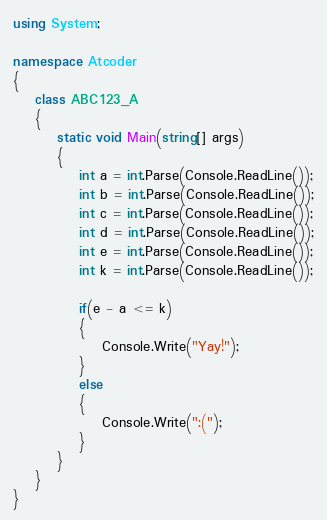<code> <loc_0><loc_0><loc_500><loc_500><_C#_>using System;

namespace Atcoder
{
    class ABC123_A
    {
        static void Main(string[] args)
        {
            int a = int.Parse(Console.ReadLine());
            int b = int.Parse(Console.ReadLine());
            int c = int.Parse(Console.ReadLine());
            int d = int.Parse(Console.ReadLine());
            int e = int.Parse(Console.ReadLine());
            int k = int.Parse(Console.ReadLine());

            if(e - a <= k)
            {
                Console.Write("Yay!");
            }
            else
            {
                Console.Write(":(");
            }
        }
    }
}
</code> 